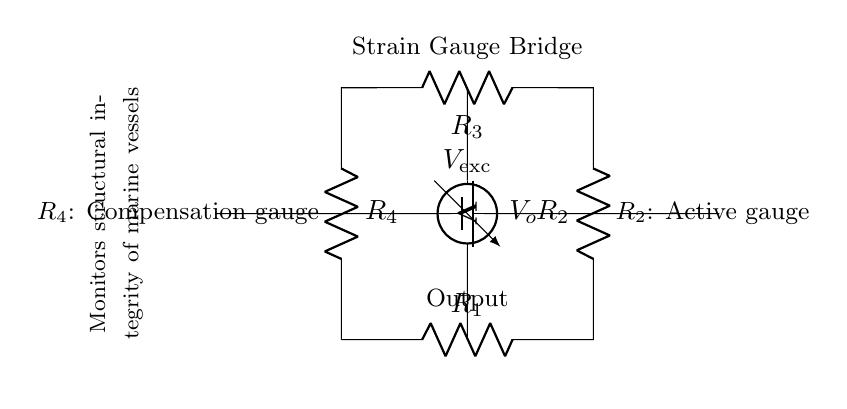What are the main components of the circuit? The main components shown in the circuit diagram are four resistors (R1, R2, R3, R4) and a voltage source (Vexc).
Answer: Four resistors and one voltage source What is the role of R2 in this strain gauge bridge circuit? R2 serves as the active gauge where the strain is applied, allowing for the measurement of the structural changes in the vessel.
Answer: Active gauge What is measured at the output terminals? At the output terminals, the circuit measures the output voltage (Vo), which reflects the unbalance created by the strain experienced in the gauge.
Answer: Output voltage How does the bridge compensate for variations? R4 is used as a compensation gauge to balance the effects of environmental factors or material imperfections, ensuring that changes in output are due solely to this strain.
Answer: Compensation gauge What indicates that this circuit monitors marine vessel integrity? The annotation near the center of the circuit indicates that it monitors structural integrity of marine vessels, emphasizing its purpose in marine applications.
Answer: Monitors structural integrity What is the significance of the voltage source in this circuit? The voltage source (Vexc) provides the excitation voltage necessary for the strain gauges to function, allowing for active measurement of strain-related changes.
Answer: Provides excitation voltage 